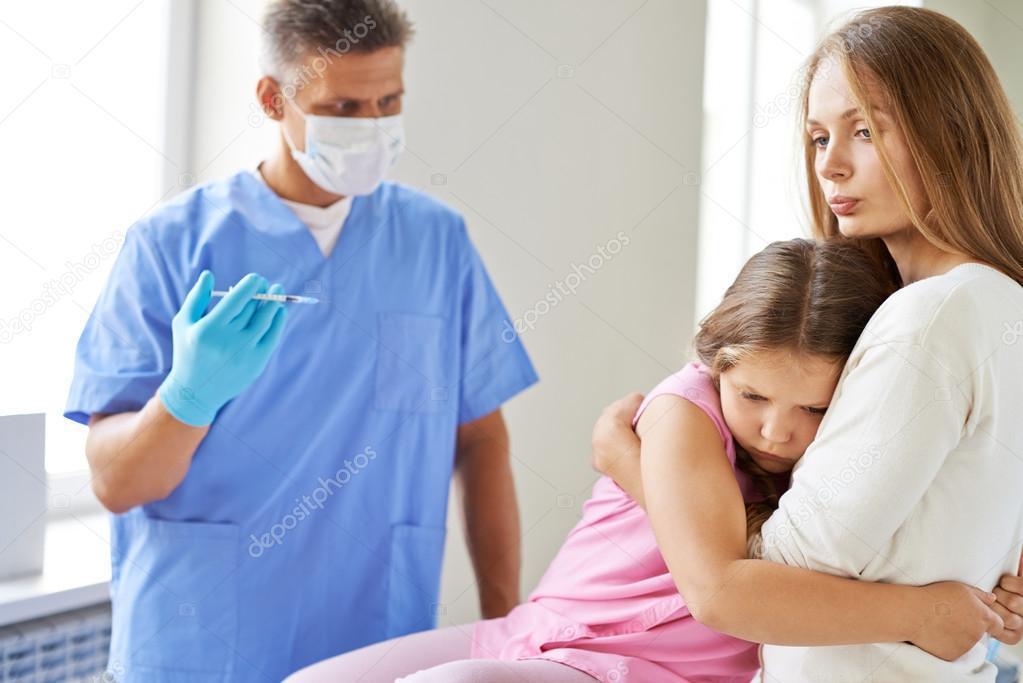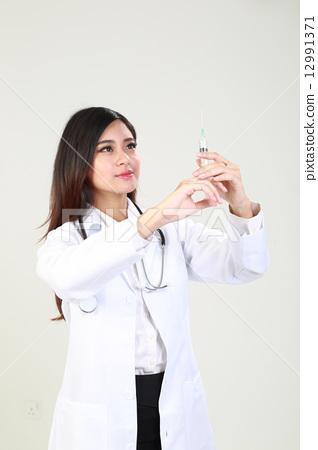The first image is the image on the left, the second image is the image on the right. For the images shown, is this caption "The right image shows a woman in a white lab coat holding up a hypodermic needle and looking at it." true? Answer yes or no. Yes. 